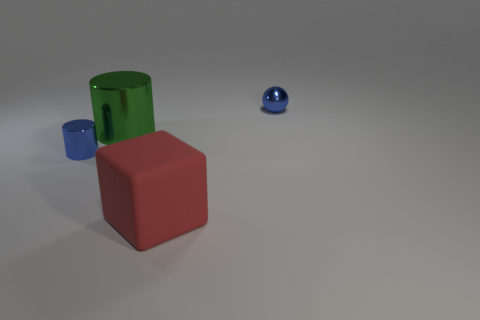Is there any other thing that has the same material as the big red thing?
Keep it short and to the point. No. Is the material of the tiny cylinder the same as the big thing that is to the left of the red block?
Provide a short and direct response. Yes. There is another metal thing that is the same size as the red thing; what is its color?
Offer a very short reply. Green. What is the size of the blue thing behind the thing left of the green shiny object?
Provide a short and direct response. Small. There is a small metallic cylinder; is its color the same as the small thing to the right of the large green cylinder?
Make the answer very short. Yes. Are there fewer large cubes that are left of the big cylinder than brown metallic blocks?
Provide a short and direct response. No. What number of other things are there of the same size as the green shiny cylinder?
Make the answer very short. 1. Is the shape of the blue object to the left of the red rubber cube the same as  the green metal object?
Your response must be concise. Yes. Are there more blue objects that are behind the green metallic thing than large cylinders?
Ensure brevity in your answer.  No. What material is the object that is both to the right of the green shiny cylinder and in front of the small ball?
Make the answer very short. Rubber. 